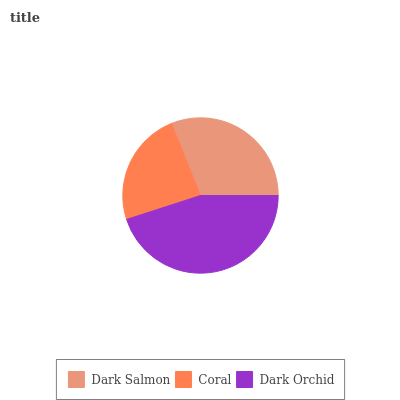Is Coral the minimum?
Answer yes or no. Yes. Is Dark Orchid the maximum?
Answer yes or no. Yes. Is Dark Orchid the minimum?
Answer yes or no. No. Is Coral the maximum?
Answer yes or no. No. Is Dark Orchid greater than Coral?
Answer yes or no. Yes. Is Coral less than Dark Orchid?
Answer yes or no. Yes. Is Coral greater than Dark Orchid?
Answer yes or no. No. Is Dark Orchid less than Coral?
Answer yes or no. No. Is Dark Salmon the high median?
Answer yes or no. Yes. Is Dark Salmon the low median?
Answer yes or no. Yes. Is Dark Orchid the high median?
Answer yes or no. No. Is Dark Orchid the low median?
Answer yes or no. No. 